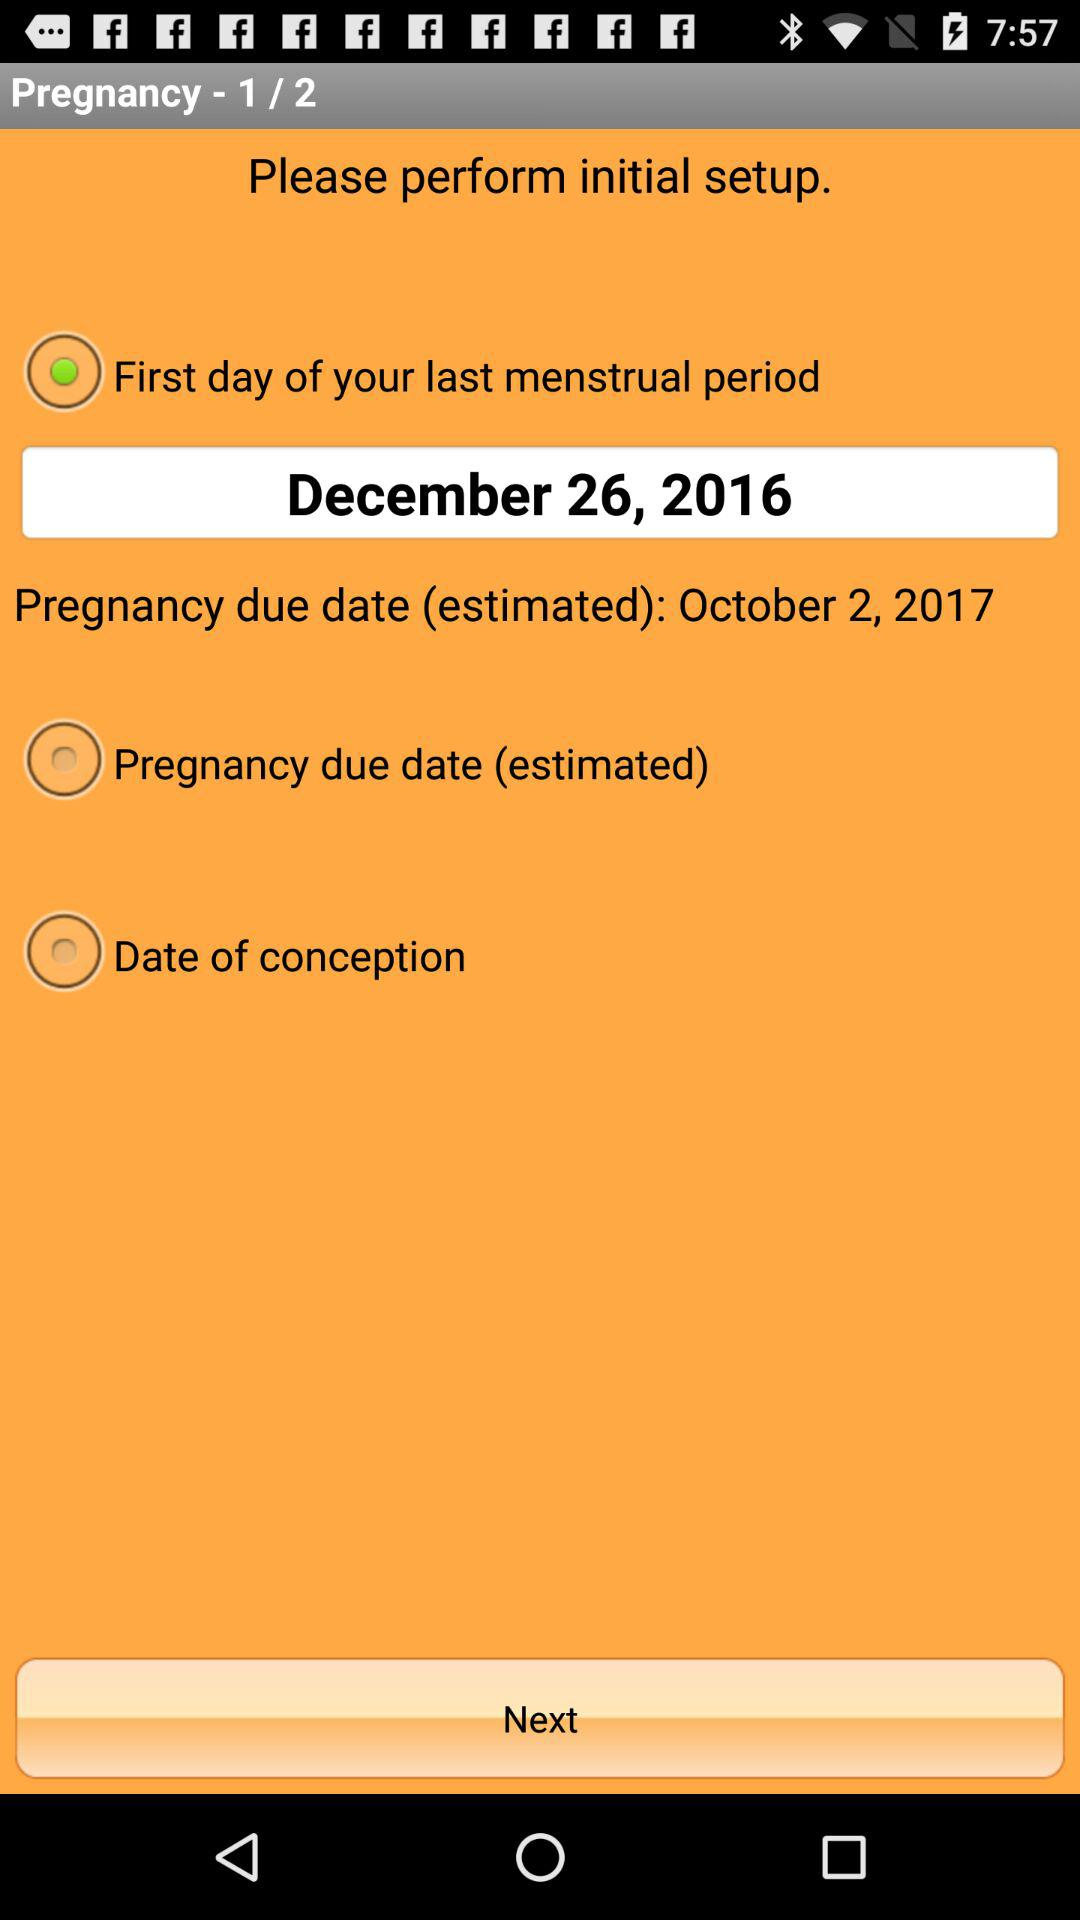What is the estimated due date of pregnancy? The estimated due date is October 2, 2017. 